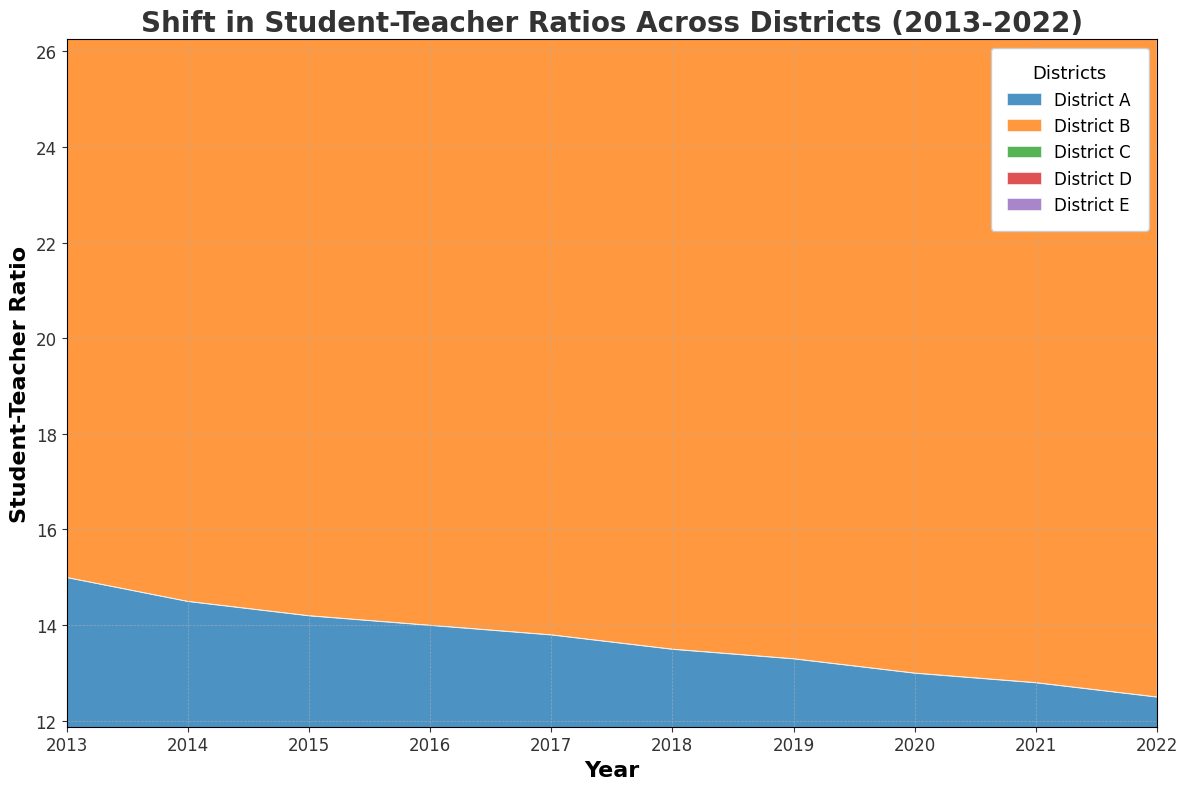What was the general trend in the student-teacher ratio for District A from 2013 to 2022? The general trend in the student-teacher ratio for District A can be observed by looking at the height of the area corresponding to District A over the years. From 2013 to 2022, the student-teacher ratio in District A gradually decreased.
Answer: Decreasing Which district had the highest student-teacher ratio in 2022? To determine the district with the highest student-teacher ratio in 2022, look at the heights of the areas at the rightmost point of the chart (2022). District E has the highest area, indicating the highest ratio.
Answer: District E By how much did the student-teacher ratio in District B change from 2013 to 2022? The student-teacher ratio in District B in 2013 was 18, and in 2022 it was 16. The change is calculated by subtracting the ratio in 2022 from the ratio in 2013. 18 - 16 = 2.
Answer: 2 Between which consecutive years did District D see the largest drop in student-teacher ratio? To find the largest drop, examine the change in height of the area for District D between consecutive years. The most significant drop seems to occur between 2016 and 2017, where the ratio went from 21.5 to 21.2.
Answer: 2016-2017 Compare the student-teacher ratio trends of District C and District E. Which district saw greater improvement over the decade? Over the decade, both District C and District E saw improvements, but District C had a more pronounced decrease in student-teacher ratio starting from 20 in 2013 to 17.8 in 2022, compared to District E which decreased from 25 to 22.5 over the same period.
Answer: District C Calculate the average student-teacher ratio for District D in odd-numbered years from 2013 to 2021. Calculate the ratios for odd-numbered years (2013, 2015, 2017, 2019, 2021), then sum them up and divide by the number of years. The values are 22, 21.9, 21.2, 20.8, 20.3 respectively. (22 + 21.9 + 21.2 + 20.8 + 20.3) / 5 = 21.24
Answer: 21.24 Between District A and District B, which district had a consistently lower student-teacher ratio throughout the decade? By comparing the areas representing District A and District B over all the years, it is evident that District A consistently had a lower student-teacher ratio compared to District B.
Answer: District A Which year had the smallest difference between the student-teacher ratios of District C and District D? To find the year with the smallest difference, observe the heights of the areas for District C and District D for each year. The difference was smallest in 2022 when District C was at 17.8 and District D was at 20, giving a difference of 2.2.
Answer: 2022 Identify a period where all districts experienced a decline in student-teacher ratios. Look for periods where the areas for all districts uniformly decline. From 2016 to 2017, all districts experienced a decline in student-teacher ratios.
Answer: 2016-2017 